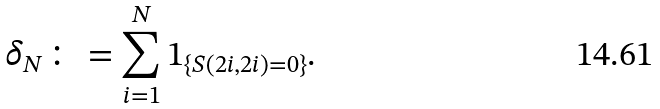<formula> <loc_0><loc_0><loc_500><loc_500>\delta _ { N } \colon = \sum _ { i = 1 } ^ { N } 1 _ { \{ S ( 2 i , 2 i ) = 0 \} } .</formula> 